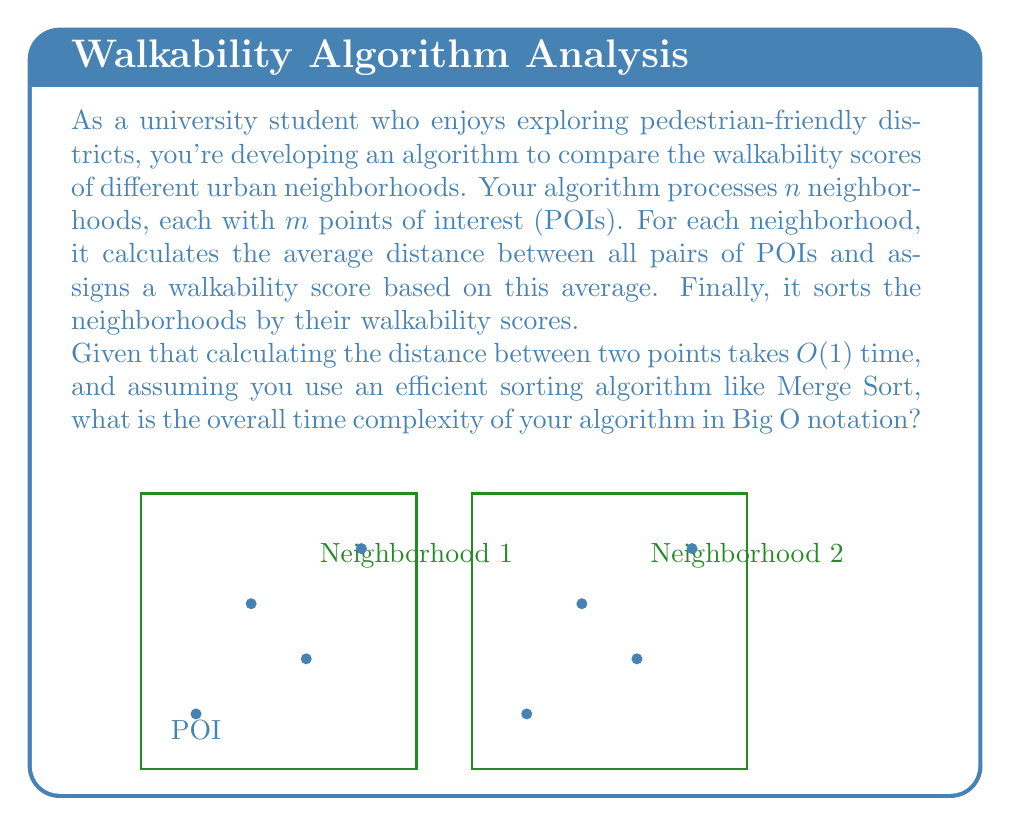Solve this math problem. Let's break down the algorithm and analyze its complexity step by step:

1) For each neighborhood (total $n$ neighborhoods):
   a) Calculate distances between all pairs of POIs:
      - There are $m$ POIs in each neighborhood
      - Number of pairs = $\binom{m}{2} = \frac{m(m-1)}{2}$
      - Each distance calculation takes $O(1)$ time
      - Total time for this step: $O(m^2)$

   b) Calculate the average distance:
      - Summing up all distances and dividing by the number of pairs
      - This takes $O(m^2)$ time (same as the previous step)

   c) Assign a walkability score based on the average:
      - This is a constant time operation, $O(1)$

   Total time for processing one neighborhood: $O(m^2)$

   Time for processing all neighborhoods: $O(nm^2)$

2) Sorting the neighborhoods based on walkability scores:
   - We have $n$ neighborhoods to sort
   - Using an efficient algorithm like Merge Sort: $O(n \log n)$

3) Overall time complexity:
   $O(nm^2 + n \log n)$

   Since $m$ could be larger than $\log n$, we can't simplify this further without additional information about the relative sizes of $n$ and $m$.

Therefore, the overall time complexity of the algorithm is $O(nm^2 + n \log n)$.
Answer: $O(nm^2 + n \log n)$ 